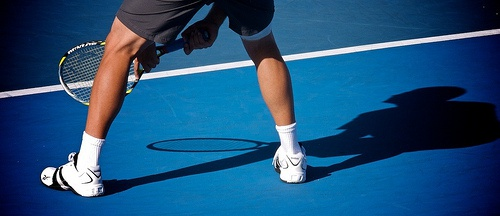Describe the objects in this image and their specific colors. I can see people in black, white, salmon, and gray tones and tennis racket in black, gray, navy, and blue tones in this image. 